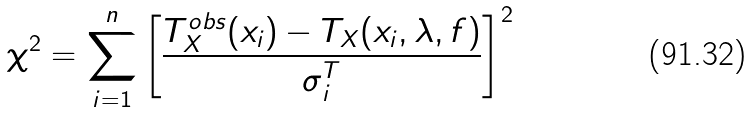<formula> <loc_0><loc_0><loc_500><loc_500>\chi ^ { 2 } = \sum _ { i = 1 } ^ { n } \left [ \frac { T _ { X } ^ { o b s } ( x _ { i } ) - T _ { X } ( x _ { i } , \lambda , f ) } { \sigma _ { i } ^ { T } } \right ] ^ { 2 } \</formula> 